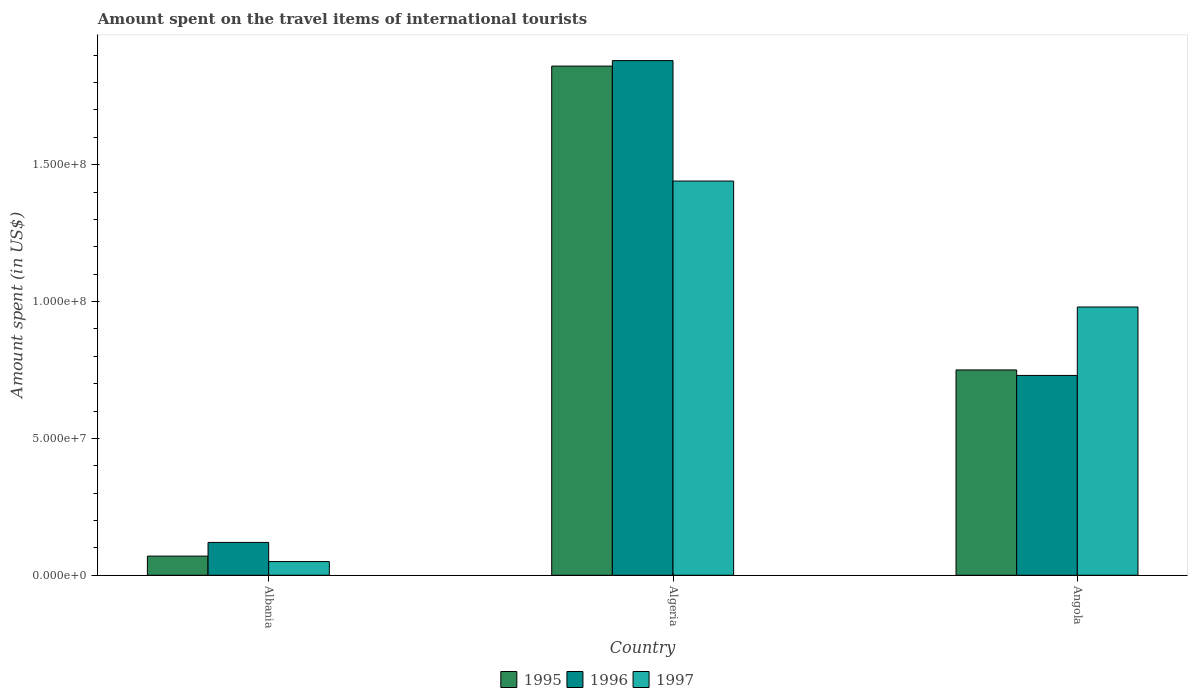Are the number of bars per tick equal to the number of legend labels?
Provide a short and direct response. Yes. Are the number of bars on each tick of the X-axis equal?
Make the answer very short. Yes. How many bars are there on the 2nd tick from the right?
Keep it short and to the point. 3. What is the label of the 1st group of bars from the left?
Keep it short and to the point. Albania. What is the amount spent on the travel items of international tourists in 1997 in Angola?
Your answer should be very brief. 9.80e+07. Across all countries, what is the maximum amount spent on the travel items of international tourists in 1995?
Give a very brief answer. 1.86e+08. Across all countries, what is the minimum amount spent on the travel items of international tourists in 1996?
Make the answer very short. 1.20e+07. In which country was the amount spent on the travel items of international tourists in 1995 maximum?
Your answer should be very brief. Algeria. In which country was the amount spent on the travel items of international tourists in 1997 minimum?
Make the answer very short. Albania. What is the total amount spent on the travel items of international tourists in 1997 in the graph?
Your response must be concise. 2.47e+08. What is the difference between the amount spent on the travel items of international tourists in 1997 in Algeria and that in Angola?
Make the answer very short. 4.60e+07. What is the difference between the amount spent on the travel items of international tourists in 1995 in Algeria and the amount spent on the travel items of international tourists in 1996 in Angola?
Provide a short and direct response. 1.13e+08. What is the average amount spent on the travel items of international tourists in 1996 per country?
Ensure brevity in your answer.  9.10e+07. What is the ratio of the amount spent on the travel items of international tourists in 1997 in Albania to that in Algeria?
Make the answer very short. 0.03. Is the amount spent on the travel items of international tourists in 1995 in Albania less than that in Angola?
Keep it short and to the point. Yes. What is the difference between the highest and the second highest amount spent on the travel items of international tourists in 1996?
Your response must be concise. 1.76e+08. What is the difference between the highest and the lowest amount spent on the travel items of international tourists in 1997?
Your response must be concise. 1.39e+08. In how many countries, is the amount spent on the travel items of international tourists in 1995 greater than the average amount spent on the travel items of international tourists in 1995 taken over all countries?
Give a very brief answer. 1. Is the sum of the amount spent on the travel items of international tourists in 1995 in Albania and Algeria greater than the maximum amount spent on the travel items of international tourists in 1997 across all countries?
Offer a very short reply. Yes. What does the 2nd bar from the right in Algeria represents?
Provide a short and direct response. 1996. Is it the case that in every country, the sum of the amount spent on the travel items of international tourists in 1996 and amount spent on the travel items of international tourists in 1995 is greater than the amount spent on the travel items of international tourists in 1997?
Provide a short and direct response. Yes. How many bars are there?
Keep it short and to the point. 9. What is the difference between two consecutive major ticks on the Y-axis?
Provide a short and direct response. 5.00e+07. Does the graph contain grids?
Provide a short and direct response. No. Where does the legend appear in the graph?
Your answer should be very brief. Bottom center. How are the legend labels stacked?
Offer a very short reply. Horizontal. What is the title of the graph?
Your response must be concise. Amount spent on the travel items of international tourists. Does "2013" appear as one of the legend labels in the graph?
Your answer should be very brief. No. What is the label or title of the Y-axis?
Ensure brevity in your answer.  Amount spent (in US$). What is the Amount spent (in US$) in 1996 in Albania?
Offer a very short reply. 1.20e+07. What is the Amount spent (in US$) of 1995 in Algeria?
Make the answer very short. 1.86e+08. What is the Amount spent (in US$) in 1996 in Algeria?
Give a very brief answer. 1.88e+08. What is the Amount spent (in US$) in 1997 in Algeria?
Your answer should be very brief. 1.44e+08. What is the Amount spent (in US$) in 1995 in Angola?
Provide a succinct answer. 7.50e+07. What is the Amount spent (in US$) of 1996 in Angola?
Your answer should be compact. 7.30e+07. What is the Amount spent (in US$) in 1997 in Angola?
Give a very brief answer. 9.80e+07. Across all countries, what is the maximum Amount spent (in US$) in 1995?
Make the answer very short. 1.86e+08. Across all countries, what is the maximum Amount spent (in US$) of 1996?
Ensure brevity in your answer.  1.88e+08. Across all countries, what is the maximum Amount spent (in US$) of 1997?
Offer a terse response. 1.44e+08. Across all countries, what is the minimum Amount spent (in US$) in 1995?
Your answer should be very brief. 7.00e+06. Across all countries, what is the minimum Amount spent (in US$) of 1996?
Your answer should be very brief. 1.20e+07. Across all countries, what is the minimum Amount spent (in US$) in 1997?
Your response must be concise. 5.00e+06. What is the total Amount spent (in US$) of 1995 in the graph?
Your answer should be compact. 2.68e+08. What is the total Amount spent (in US$) in 1996 in the graph?
Ensure brevity in your answer.  2.73e+08. What is the total Amount spent (in US$) of 1997 in the graph?
Offer a terse response. 2.47e+08. What is the difference between the Amount spent (in US$) in 1995 in Albania and that in Algeria?
Your answer should be very brief. -1.79e+08. What is the difference between the Amount spent (in US$) in 1996 in Albania and that in Algeria?
Keep it short and to the point. -1.76e+08. What is the difference between the Amount spent (in US$) in 1997 in Albania and that in Algeria?
Offer a very short reply. -1.39e+08. What is the difference between the Amount spent (in US$) in 1995 in Albania and that in Angola?
Your response must be concise. -6.80e+07. What is the difference between the Amount spent (in US$) of 1996 in Albania and that in Angola?
Provide a short and direct response. -6.10e+07. What is the difference between the Amount spent (in US$) in 1997 in Albania and that in Angola?
Ensure brevity in your answer.  -9.30e+07. What is the difference between the Amount spent (in US$) of 1995 in Algeria and that in Angola?
Offer a terse response. 1.11e+08. What is the difference between the Amount spent (in US$) in 1996 in Algeria and that in Angola?
Offer a terse response. 1.15e+08. What is the difference between the Amount spent (in US$) in 1997 in Algeria and that in Angola?
Offer a terse response. 4.60e+07. What is the difference between the Amount spent (in US$) in 1995 in Albania and the Amount spent (in US$) in 1996 in Algeria?
Give a very brief answer. -1.81e+08. What is the difference between the Amount spent (in US$) of 1995 in Albania and the Amount spent (in US$) of 1997 in Algeria?
Keep it short and to the point. -1.37e+08. What is the difference between the Amount spent (in US$) in 1996 in Albania and the Amount spent (in US$) in 1997 in Algeria?
Ensure brevity in your answer.  -1.32e+08. What is the difference between the Amount spent (in US$) of 1995 in Albania and the Amount spent (in US$) of 1996 in Angola?
Give a very brief answer. -6.60e+07. What is the difference between the Amount spent (in US$) in 1995 in Albania and the Amount spent (in US$) in 1997 in Angola?
Offer a very short reply. -9.10e+07. What is the difference between the Amount spent (in US$) in 1996 in Albania and the Amount spent (in US$) in 1997 in Angola?
Your answer should be compact. -8.60e+07. What is the difference between the Amount spent (in US$) in 1995 in Algeria and the Amount spent (in US$) in 1996 in Angola?
Offer a terse response. 1.13e+08. What is the difference between the Amount spent (in US$) of 1995 in Algeria and the Amount spent (in US$) of 1997 in Angola?
Your answer should be compact. 8.80e+07. What is the difference between the Amount spent (in US$) of 1996 in Algeria and the Amount spent (in US$) of 1997 in Angola?
Offer a terse response. 9.00e+07. What is the average Amount spent (in US$) of 1995 per country?
Your answer should be very brief. 8.93e+07. What is the average Amount spent (in US$) of 1996 per country?
Offer a terse response. 9.10e+07. What is the average Amount spent (in US$) in 1997 per country?
Your answer should be compact. 8.23e+07. What is the difference between the Amount spent (in US$) in 1995 and Amount spent (in US$) in 1996 in Albania?
Ensure brevity in your answer.  -5.00e+06. What is the difference between the Amount spent (in US$) of 1995 and Amount spent (in US$) of 1997 in Algeria?
Give a very brief answer. 4.20e+07. What is the difference between the Amount spent (in US$) in 1996 and Amount spent (in US$) in 1997 in Algeria?
Your answer should be very brief. 4.40e+07. What is the difference between the Amount spent (in US$) of 1995 and Amount spent (in US$) of 1996 in Angola?
Offer a terse response. 2.00e+06. What is the difference between the Amount spent (in US$) in 1995 and Amount spent (in US$) in 1997 in Angola?
Your answer should be very brief. -2.30e+07. What is the difference between the Amount spent (in US$) in 1996 and Amount spent (in US$) in 1997 in Angola?
Offer a very short reply. -2.50e+07. What is the ratio of the Amount spent (in US$) of 1995 in Albania to that in Algeria?
Your response must be concise. 0.04. What is the ratio of the Amount spent (in US$) in 1996 in Albania to that in Algeria?
Ensure brevity in your answer.  0.06. What is the ratio of the Amount spent (in US$) of 1997 in Albania to that in Algeria?
Your answer should be compact. 0.03. What is the ratio of the Amount spent (in US$) of 1995 in Albania to that in Angola?
Offer a terse response. 0.09. What is the ratio of the Amount spent (in US$) in 1996 in Albania to that in Angola?
Your answer should be very brief. 0.16. What is the ratio of the Amount spent (in US$) of 1997 in Albania to that in Angola?
Offer a terse response. 0.05. What is the ratio of the Amount spent (in US$) in 1995 in Algeria to that in Angola?
Ensure brevity in your answer.  2.48. What is the ratio of the Amount spent (in US$) of 1996 in Algeria to that in Angola?
Your answer should be compact. 2.58. What is the ratio of the Amount spent (in US$) in 1997 in Algeria to that in Angola?
Give a very brief answer. 1.47. What is the difference between the highest and the second highest Amount spent (in US$) in 1995?
Keep it short and to the point. 1.11e+08. What is the difference between the highest and the second highest Amount spent (in US$) of 1996?
Your answer should be compact. 1.15e+08. What is the difference between the highest and the second highest Amount spent (in US$) of 1997?
Provide a short and direct response. 4.60e+07. What is the difference between the highest and the lowest Amount spent (in US$) of 1995?
Make the answer very short. 1.79e+08. What is the difference between the highest and the lowest Amount spent (in US$) of 1996?
Offer a very short reply. 1.76e+08. What is the difference between the highest and the lowest Amount spent (in US$) of 1997?
Offer a very short reply. 1.39e+08. 